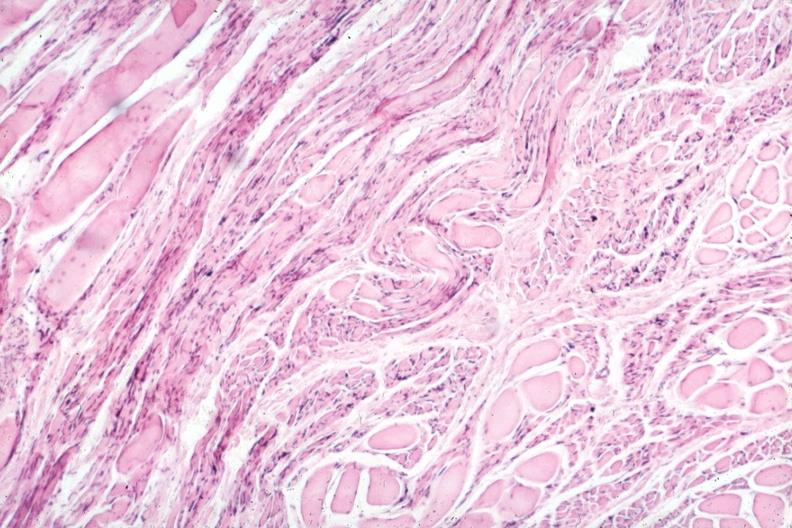what does this image show?
Answer the question using a single word or phrase. Marked neurological atrophy 